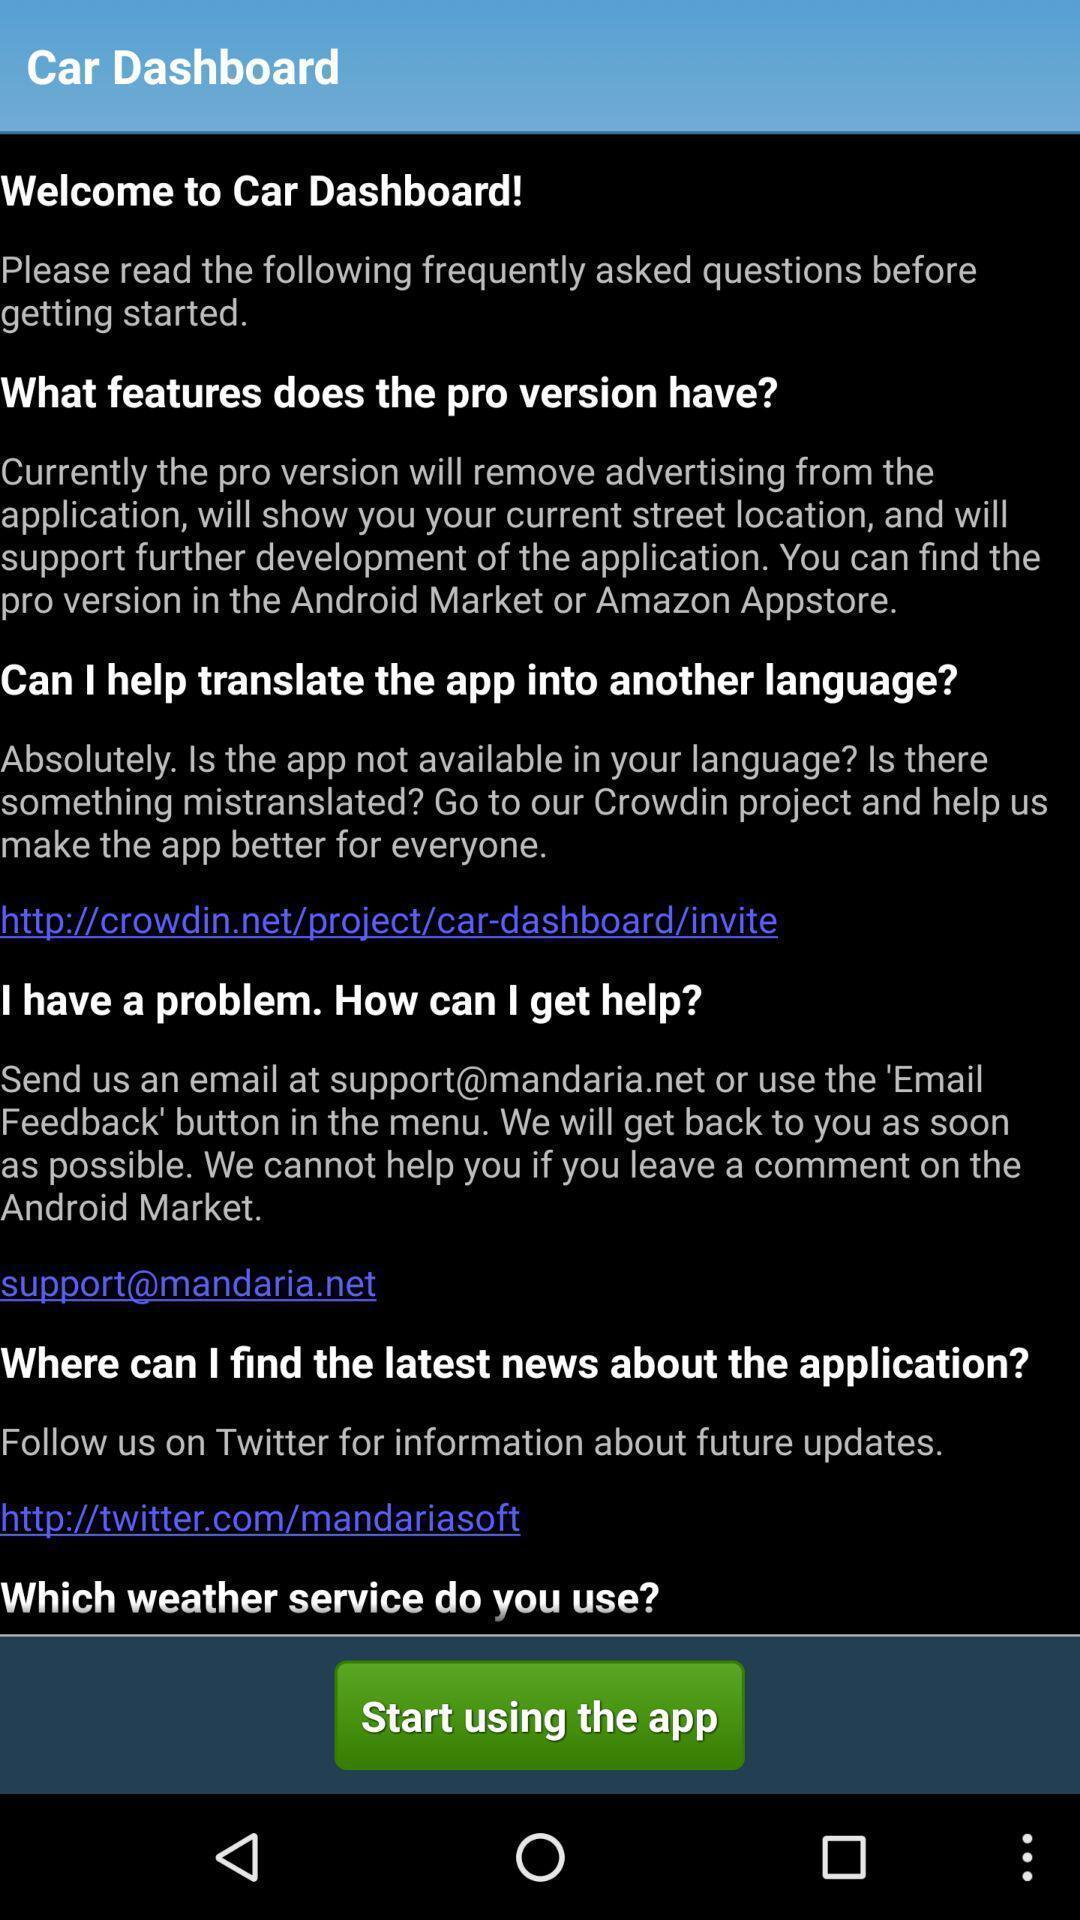What details can you identify in this image? Page with all inquires of car dashboard. 